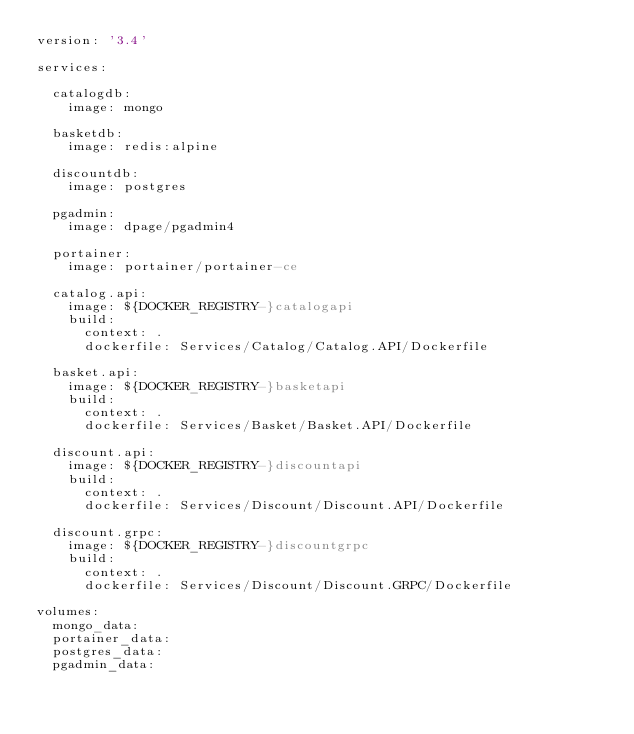<code> <loc_0><loc_0><loc_500><loc_500><_YAML_>version: '3.4'

services:
  
  catalogdb:
    image: mongo
  
  basketdb:
    image: redis:alpine

  discountdb:
    image: postgres

  pgadmin:
    image: dpage/pgadmin4

  portainer:
    image: portainer/portainer-ce

  catalog.api:
    image: ${DOCKER_REGISTRY-}catalogapi
    build:
      context: .
      dockerfile: Services/Catalog/Catalog.API/Dockerfile

  basket.api:
    image: ${DOCKER_REGISTRY-}basketapi
    build:
      context: .
      dockerfile: Services/Basket/Basket.API/Dockerfile

  discount.api:
    image: ${DOCKER_REGISTRY-}discountapi
    build:
      context: .
      dockerfile: Services/Discount/Discount.API/Dockerfile

  discount.grpc:
    image: ${DOCKER_REGISTRY-}discountgrpc
    build:
      context: .
      dockerfile: Services/Discount/Discount.GRPC/Dockerfile

volumes:
  mongo_data:
  portainer_data:
  postgres_data:
  pgadmin_data:


</code> 